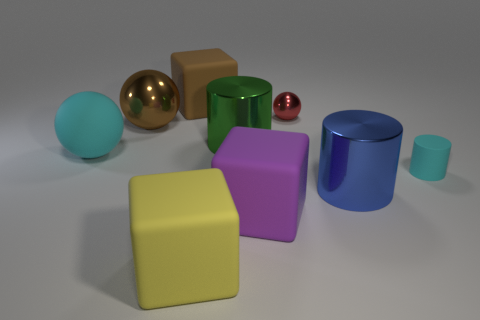Subtract all cyan spheres. How many spheres are left? 2 Subtract all shiny balls. How many balls are left? 1 Subtract all blocks. How many objects are left? 6 Subtract 1 spheres. How many spheres are left? 2 Add 1 brown things. How many objects exist? 10 Subtract all red cubes. How many brown cylinders are left? 0 Subtract all purple spheres. Subtract all red blocks. How many spheres are left? 3 Subtract all cyan things. Subtract all cyan rubber objects. How many objects are left? 5 Add 7 small red metallic spheres. How many small red metallic spheres are left? 8 Add 4 large matte things. How many large matte things exist? 8 